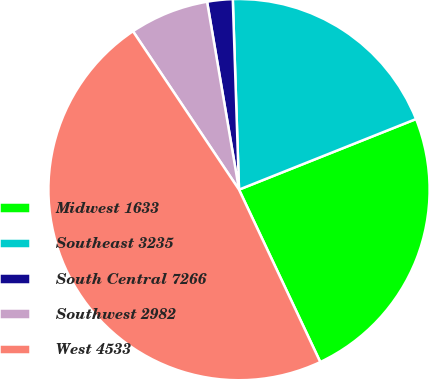Convert chart. <chart><loc_0><loc_0><loc_500><loc_500><pie_chart><fcel>Midwest 1633<fcel>Southeast 3235<fcel>South Central 7266<fcel>Southwest 2982<fcel>West 4533<nl><fcel>24.03%<fcel>19.48%<fcel>2.16%<fcel>6.71%<fcel>47.62%<nl></chart> 